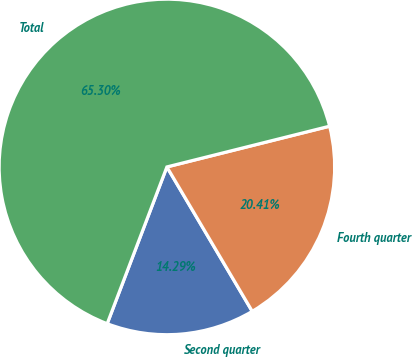<chart> <loc_0><loc_0><loc_500><loc_500><pie_chart><fcel>Second quarter<fcel>Fourth quarter<fcel>Total<nl><fcel>14.29%<fcel>20.41%<fcel>65.31%<nl></chart> 